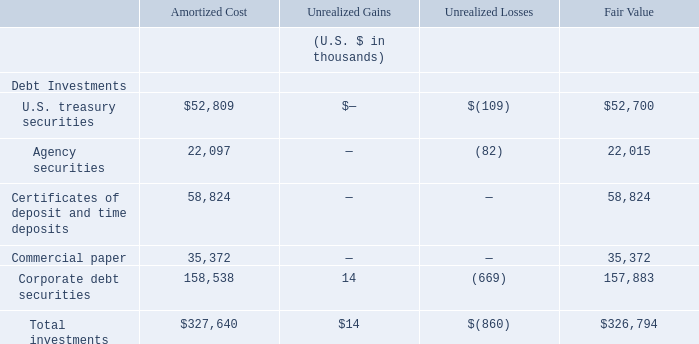As of June 30, 2018, the Group’s investments consisted of the following:
As of June 30, 2018, the Group had $323.1 million of investments which were classified as short-term investments on the Group’s consolidated statements of financial position. Additionally, the Group had certificates of deposit and time deposits totaling $3.6 million which were classified as long-term and were included in other non- current assets on the Group’s consolidated statements of financial position.
As of June 30, 2018, what is the value of the certificates of deposit and time deposits? $3.6 million. As of June 30, 2018, what is the value of short-term investments on the Group's consolidated statements of financial position? $323.1 million. What is the amount of total investments based on fair value?
Answer scale should be: thousand. $326,794. Based on fair value, what is the difference in value between U.S. treasury securities and agency securities?
Answer scale should be: thousand. 52,700-22,015
Answer: 30685. Based on amortized cost, what is the percentage constitution of Agency securities among the total investments?
Answer scale should be: percent. 22,097/327,640
Answer: 6.74. Based on fair value, what is the percentage constitution of corporate debt securities among the total investments?
Answer scale should be: percent. 157,883/326,794
Answer: 48.31. 